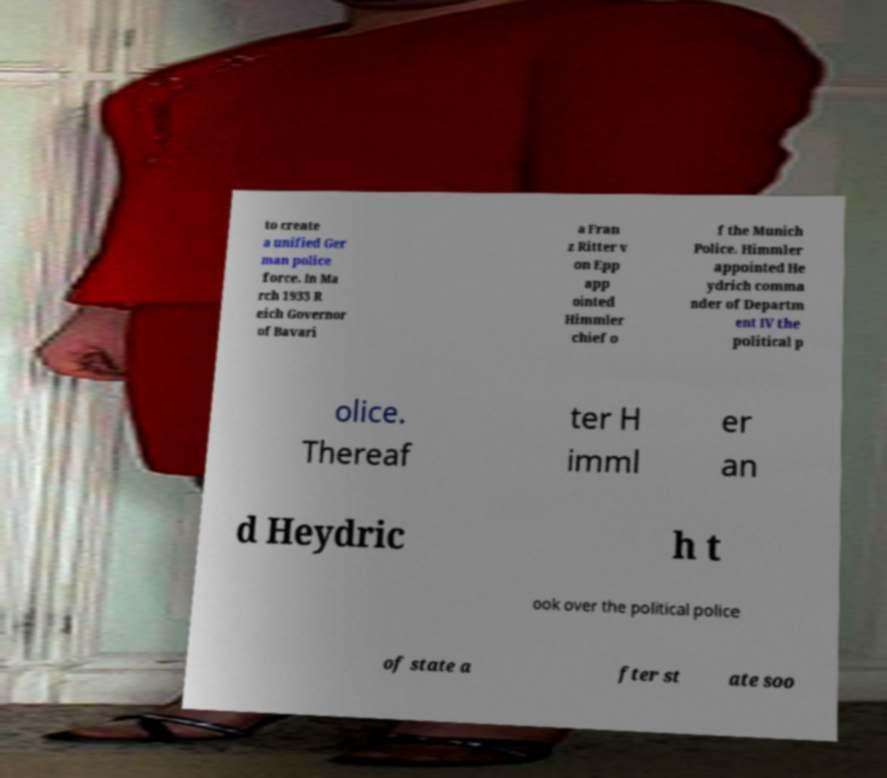Please identify and transcribe the text found in this image. to create a unified Ger man police force. In Ma rch 1933 R eich Governor of Bavari a Fran z Ritter v on Epp app ointed Himmler chief o f the Munich Police. Himmler appointed He ydrich comma nder of Departm ent IV the political p olice. Thereaf ter H imml er an d Heydric h t ook over the political police of state a fter st ate soo 